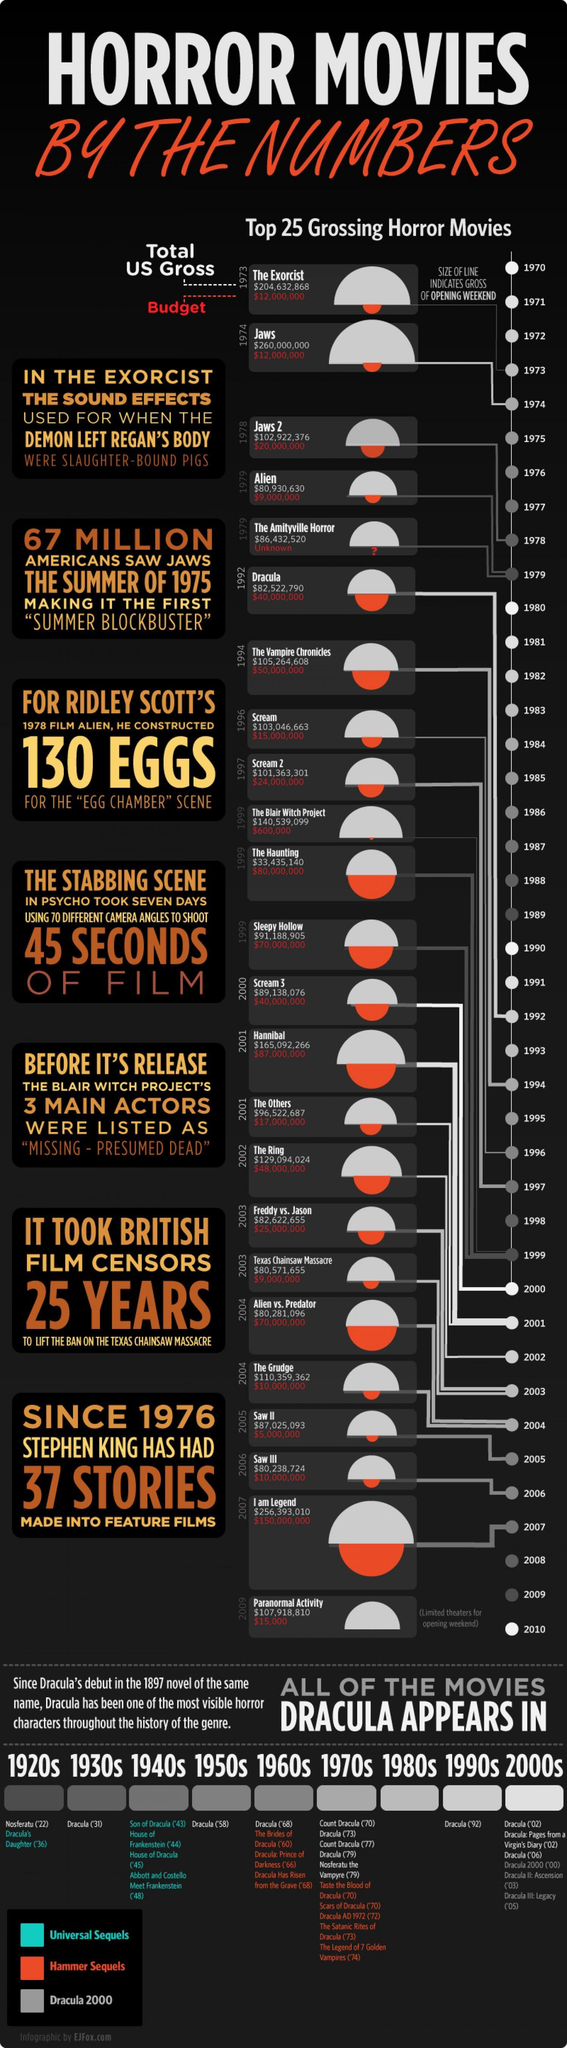How many stories were made into feature films by Stephen King since 1976?
Answer the question with a short phrase. 37 STORIES What was the budget for the movie 'The Ring'? $48,000,000 How many years were taken by the British Film Censors to lift the ban on the Texas Chainsaw Massacre? 25 YEARS When was the movie 'The Grudge' released? 2004 What is the total US gross amount for the movie 'Jaws'? $260,000,000 What was the budget amount for the movie 'Sleepy Hollow'? $70,000,000 When was the movie 'I am Legend' released? 2007 What is the total US gross amount for the movie 'Alien'? $80,930,630 In which year, the movie 'Hannibal' was released? 2001 